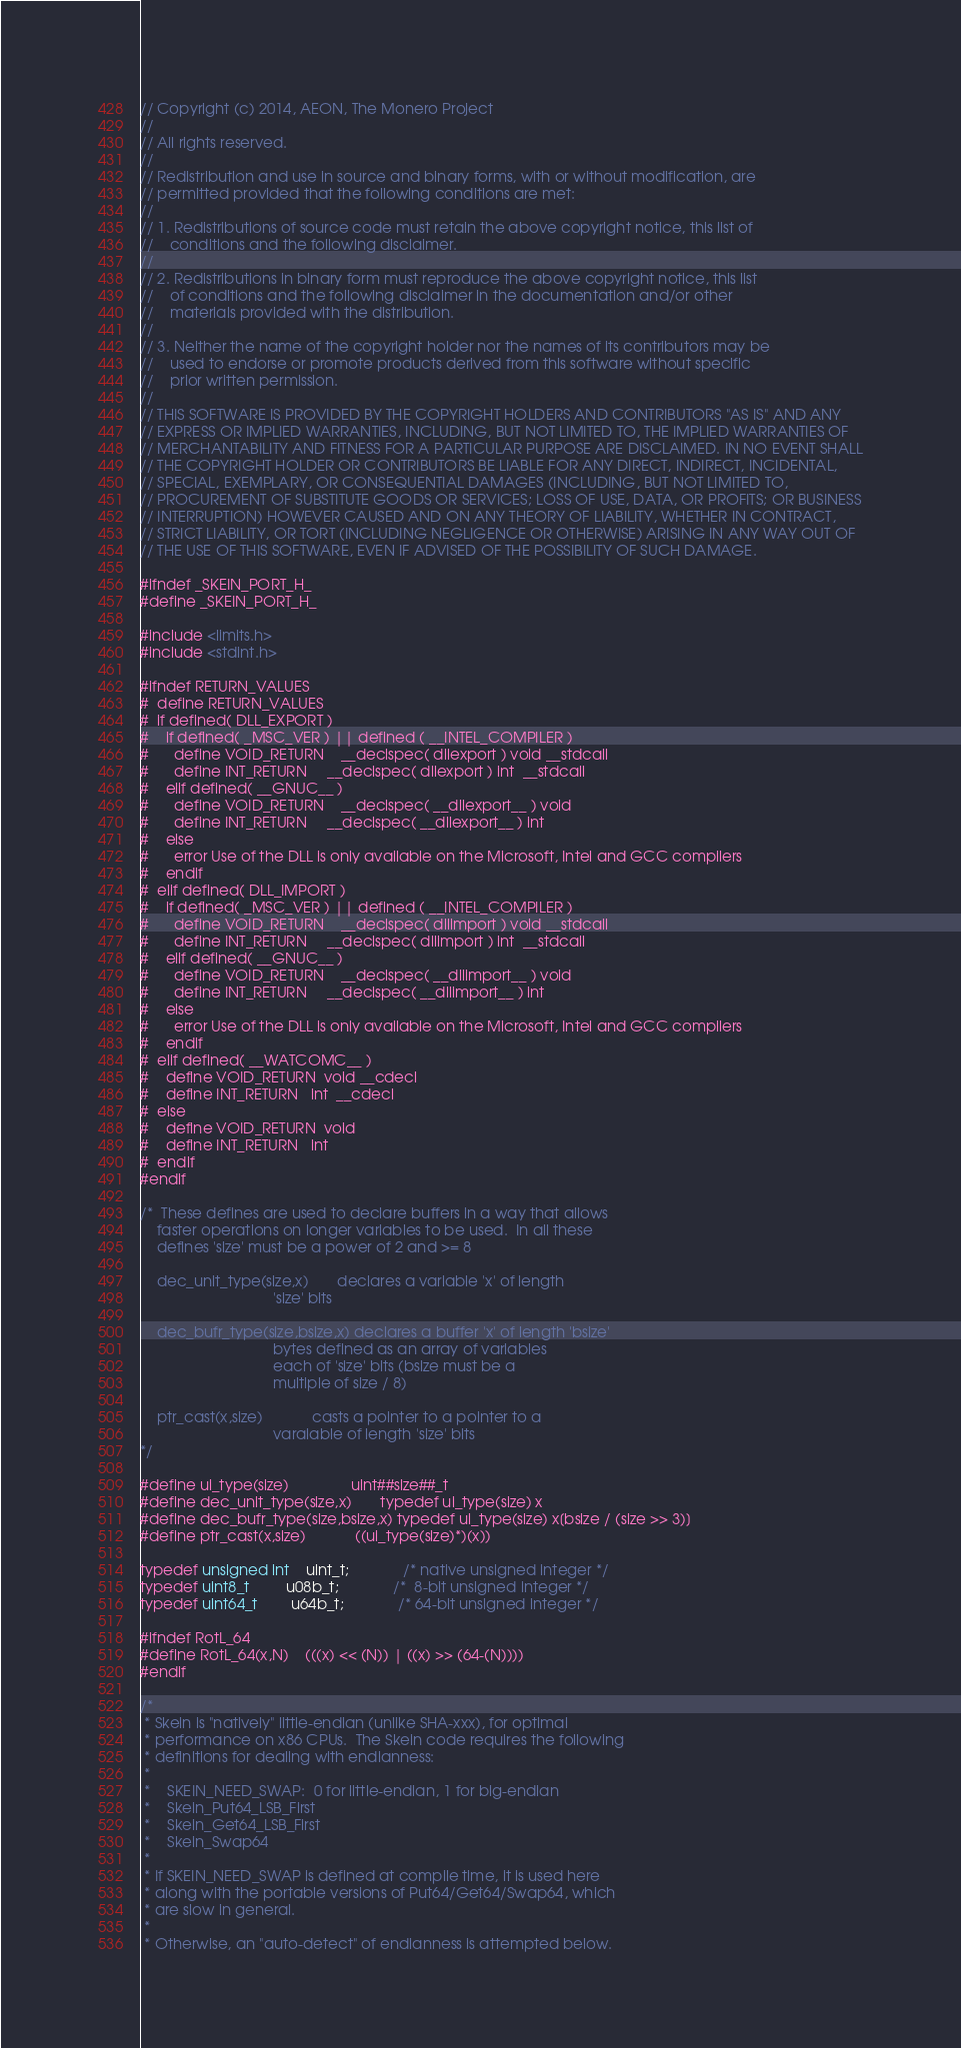Convert code to text. <code><loc_0><loc_0><loc_500><loc_500><_C_>// Copyright (c) 2014, AEON, The Monero Project
// 
// All rights reserved.
// 
// Redistribution and use in source and binary forms, with or without modification, are
// permitted provided that the following conditions are met:
// 
// 1. Redistributions of source code must retain the above copyright notice, this list of
//    conditions and the following disclaimer.
// 
// 2. Redistributions in binary form must reproduce the above copyright notice, this list
//    of conditions and the following disclaimer in the documentation and/or other
//    materials provided with the distribution.
// 
// 3. Neither the name of the copyright holder nor the names of its contributors may be
//    used to endorse or promote products derived from this software without specific
//    prior written permission.
// 
// THIS SOFTWARE IS PROVIDED BY THE COPYRIGHT HOLDERS AND CONTRIBUTORS "AS IS" AND ANY
// EXPRESS OR IMPLIED WARRANTIES, INCLUDING, BUT NOT LIMITED TO, THE IMPLIED WARRANTIES OF
// MERCHANTABILITY AND FITNESS FOR A PARTICULAR PURPOSE ARE DISCLAIMED. IN NO EVENT SHALL
// THE COPYRIGHT HOLDER OR CONTRIBUTORS BE LIABLE FOR ANY DIRECT, INDIRECT, INCIDENTAL,
// SPECIAL, EXEMPLARY, OR CONSEQUENTIAL DAMAGES (INCLUDING, BUT NOT LIMITED TO,
// PROCUREMENT OF SUBSTITUTE GOODS OR SERVICES; LOSS OF USE, DATA, OR PROFITS; OR BUSINESS
// INTERRUPTION) HOWEVER CAUSED AND ON ANY THEORY OF LIABILITY, WHETHER IN CONTRACT,
// STRICT LIABILITY, OR TORT (INCLUDING NEGLIGENCE OR OTHERWISE) ARISING IN ANY WAY OUT OF
// THE USE OF THIS SOFTWARE, EVEN IF ADVISED OF THE POSSIBILITY OF SUCH DAMAGE.

#ifndef _SKEIN_PORT_H_
#define _SKEIN_PORT_H_

#include <limits.h>
#include <stdint.h>

#ifndef RETURN_VALUES
#  define RETURN_VALUES
#  if defined( DLL_EXPORT )
#    if defined( _MSC_VER ) || defined ( __INTEL_COMPILER )
#      define VOID_RETURN    __declspec( dllexport ) void __stdcall
#      define INT_RETURN     __declspec( dllexport ) int  __stdcall
#    elif defined( __GNUC__ )
#      define VOID_RETURN    __declspec( __dllexport__ ) void
#      define INT_RETURN     __declspec( __dllexport__ ) int
#    else
#      error Use of the DLL is only available on the Microsoft, Intel and GCC compilers
#    endif
#  elif defined( DLL_IMPORT )
#    if defined( _MSC_VER ) || defined ( __INTEL_COMPILER )
#      define VOID_RETURN    __declspec( dllimport ) void __stdcall
#      define INT_RETURN     __declspec( dllimport ) int  __stdcall
#    elif defined( __GNUC__ )
#      define VOID_RETURN    __declspec( __dllimport__ ) void
#      define INT_RETURN     __declspec( __dllimport__ ) int
#    else
#      error Use of the DLL is only available on the Microsoft, Intel and GCC compilers
#    endif
#  elif defined( __WATCOMC__ )
#    define VOID_RETURN  void __cdecl
#    define INT_RETURN   int  __cdecl
#  else
#    define VOID_RETURN  void
#    define INT_RETURN   int
#  endif
#endif

/*  These defines are used to declare buffers in a way that allows
    faster operations on longer variables to be used.  In all these
    defines 'size' must be a power of 2 and >= 8

    dec_unit_type(size,x)       declares a variable 'x' of length 
                                'size' bits

    dec_bufr_type(size,bsize,x) declares a buffer 'x' of length 'bsize' 
                                bytes defined as an array of variables
                                each of 'size' bits (bsize must be a 
                                multiple of size / 8)

    ptr_cast(x,size)            casts a pointer to a pointer to a 
                                varaiable of length 'size' bits
*/

#define ui_type(size)               uint##size##_t
#define dec_unit_type(size,x)       typedef ui_type(size) x
#define dec_bufr_type(size,bsize,x) typedef ui_type(size) x[bsize / (size >> 3)]
#define ptr_cast(x,size)            ((ui_type(size)*)(x))

typedef unsigned int    uint_t;             /* native unsigned integer */
typedef uint8_t         u08b_t;             /*  8-bit unsigned integer */
typedef uint64_t        u64b_t;             /* 64-bit unsigned integer */

#ifndef RotL_64
#define RotL_64(x,N)    (((x) << (N)) | ((x) >> (64-(N))))
#endif

/*
 * Skein is "natively" little-endian (unlike SHA-xxx), for optimal
 * performance on x86 CPUs.  The Skein code requires the following
 * definitions for dealing with endianness:
 *
 *    SKEIN_NEED_SWAP:  0 for little-endian, 1 for big-endian
 *    Skein_Put64_LSB_First
 *    Skein_Get64_LSB_First
 *    Skein_Swap64
 *
 * If SKEIN_NEED_SWAP is defined at compile time, it is used here
 * along with the portable versions of Put64/Get64/Swap64, which 
 * are slow in general.
 *
 * Otherwise, an "auto-detect" of endianness is attempted below.</code> 